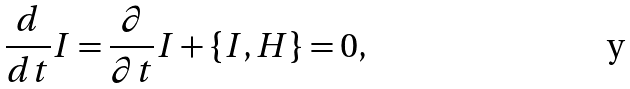Convert formula to latex. <formula><loc_0><loc_0><loc_500><loc_500>\frac { d } { d t } I = \frac { \partial } { \partial t } I + \{ I , H \} = 0 ,</formula> 